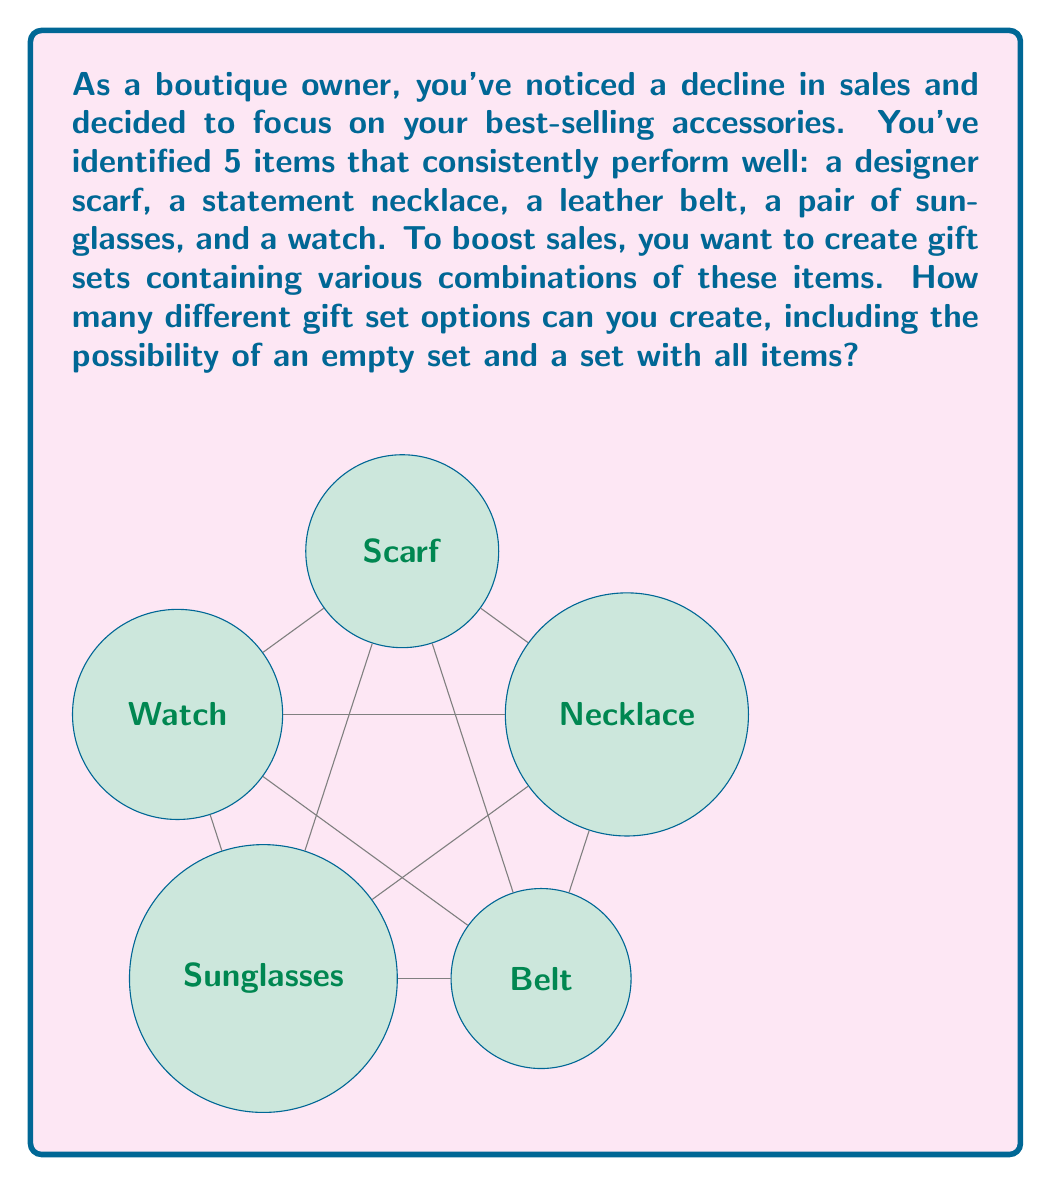Could you help me with this problem? Let's approach this step-by-step:

1) First, we need to understand what we're calculating. We're looking for the number of all possible subsets of our 5 best-selling accessories, which is the definition of a power set.

2) The cardinality of a power set is given by the formula:

   $$|P(A)| = 2^n$$

   Where $n$ is the number of elements in the original set $A$.

3) In our case, we have 5 accessories:
   - Designer scarf
   - Statement necklace
   - Leather belt
   - Sunglasses
   - Watch

   So, $n = 5$

4) Plugging this into our formula:

   $$|P(A)| = 2^5$$

5) Now, let's calculate $2^5$:

   $$2^5 = 2 \times 2 \times 2 \times 2 \times 2 = 32$$

6) This result, 32, represents:
   - The empty set (no accessories)
   - 5 sets with one accessory each
   - 10 sets with two accessories each
   - 10 sets with three accessories each
   - 5 sets with four accessories each
   - 1 set with all five accessories

Therefore, you can create 32 different gift set options from your 5 best-selling accessories.
Answer: $32$ 